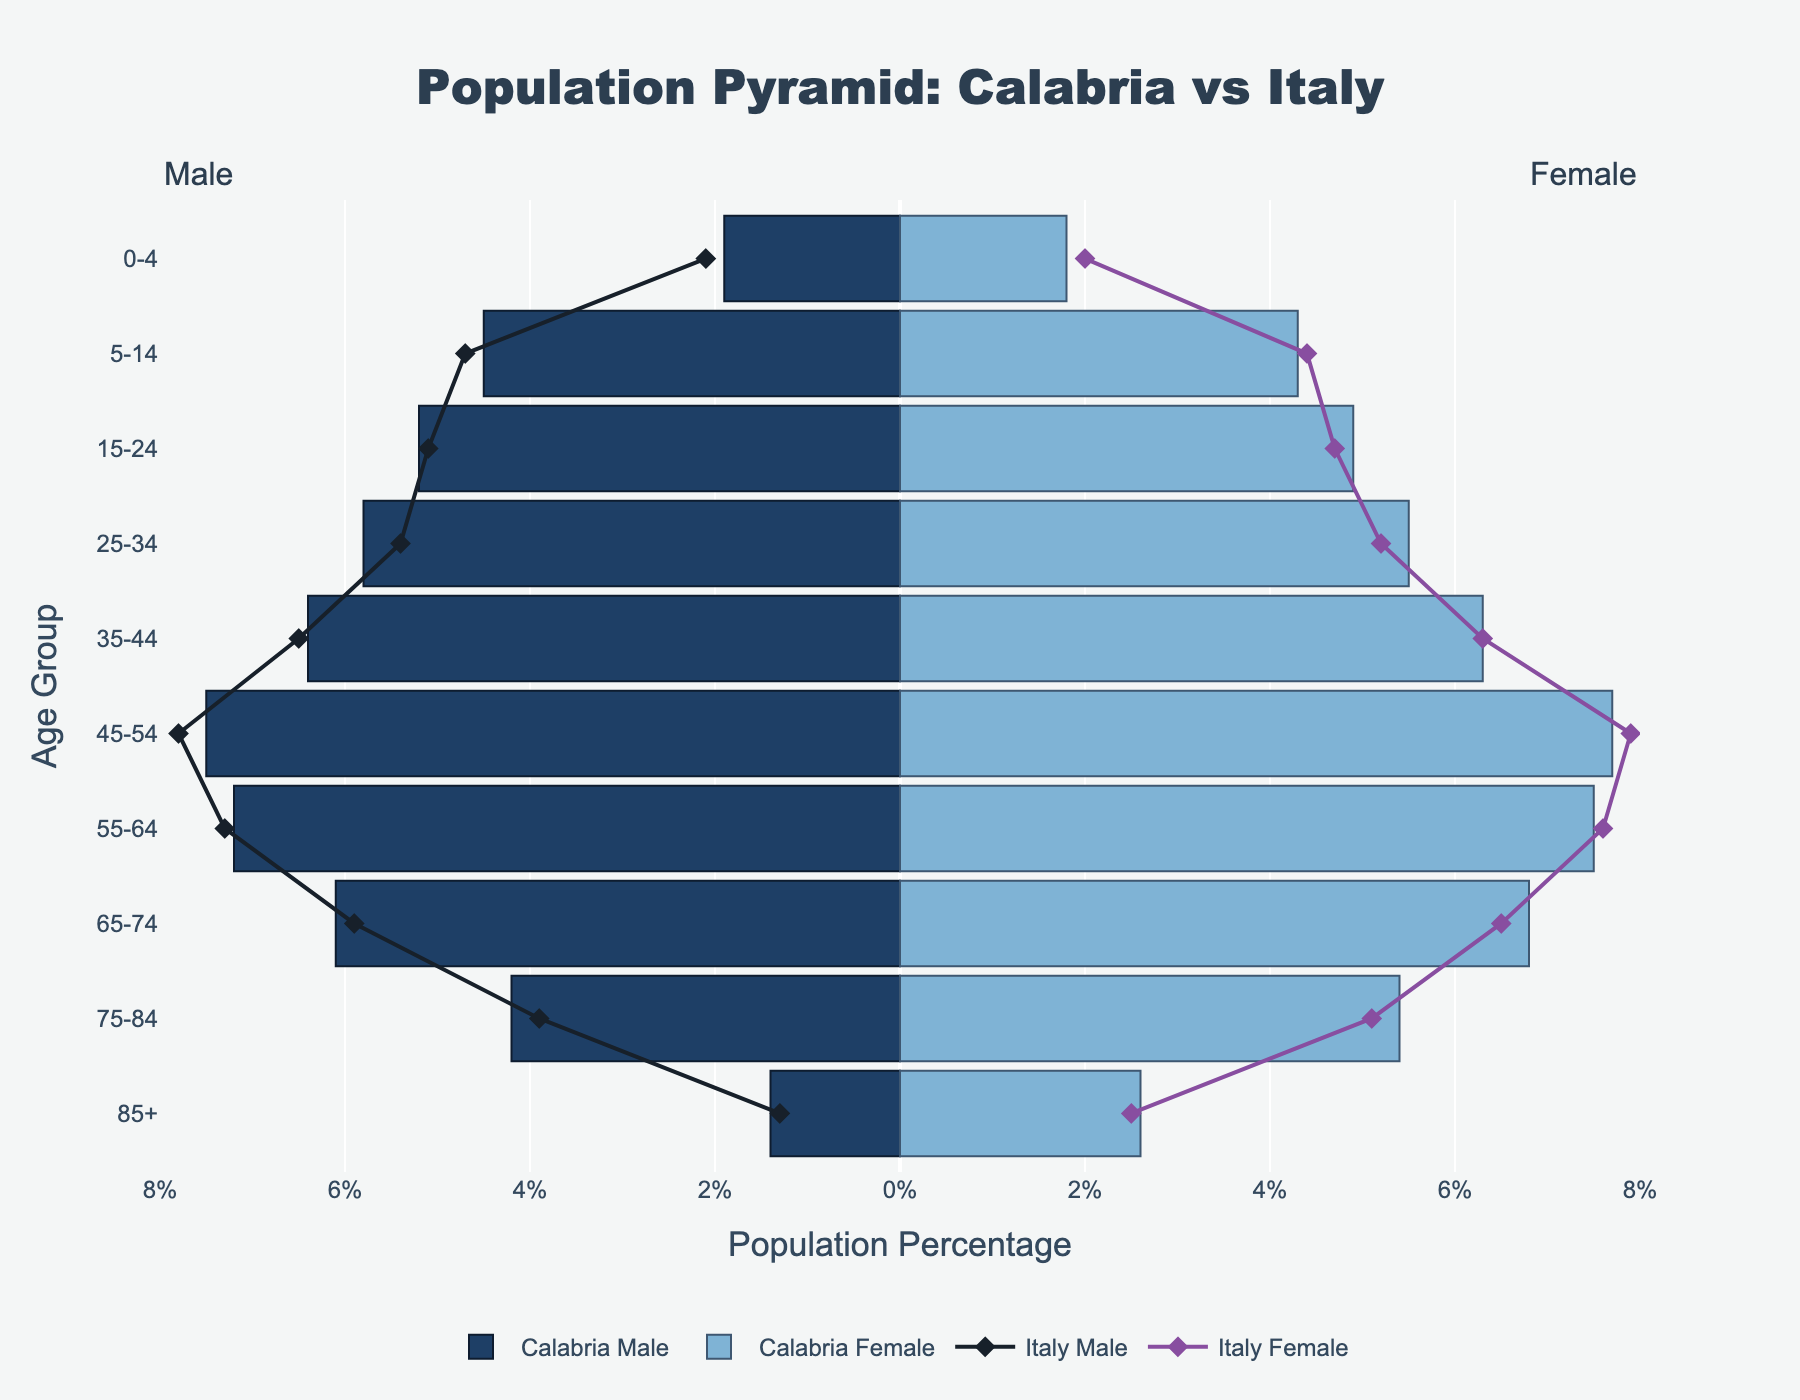What age group has the highest percentage of males in Calabria? The highest percentage of males in Calabria can be determined by looking at the bar lengths on the negative X-axis. The age group with the longest bar is the 45-54 group with 7.5%.
Answer: 45-54 What is the percentage difference between Calabria and Italy for males aged 0-4? The percentage for Calabria males aged 0-4 is 1.9%, and for Italy, it is 2.1%. The difference is calculated as 2.1% - 1.9% = 0.2%.
Answer: 0.2% How does the female population percentage in Calabria compare to Italy for the age group 85+? For the 85+ age group, Calabria has a female percentage of 2.6%, while Italy has a female percentage of 2.5%. Comparing these, Calabria is slightly higher.
Answer: Calabria is slightly higher Which age group has the largest difference between male and female percentages in Calabria? To find this, we compare the differences between male and female percentages for each age group. The age group 85+ shows the largest difference: 2.6% (female) - 1.4% (male) = 1.2%.
Answer: 85+ What age group shows a higher percentage for females compared to males in both Calabria and Italy? The age groups where both Calabria and Italy show females percentages higher than males percentages can be seen in the 45-54, 55-64, 65-74, 75-84, and 85+ age groups.
Answer: 45-54, 55-64, 65-74, 75-84, 85+ What is the total percentage of Calabria's population aged 25-44? Add the percentages of the age groups 25-34 (5.8% males + 5.5% females) and 35-44 (6.4% males + 6.3% females): 5.8 + 5.5 + 6.4 + 6.3 = 24%.
Answer: 24% Is the percentage of Calabria's female population aged 45-54 higher than Italy's? Compare the percentages: Calabria females aged 45-54 are 7.7%, and Italy females aged 45-54 are 7.9%. Therefore, Calabria is slightly lower.
Answer: No In which age group does Calabria have the largest male population percentage compared to Italy? Scanning the male bars, the largest difference where Calabria's percentage exceeds Italy's is the age group 25-34: Calabria 5.8% vs. Italy 5.4%.
Answer: 25-34 What is the percentage difference between males and females in Calabria for the age group 75-84? The percentage for Calabria males aged 75-84 is 4.2%, and for Calabria females, it is 5.4%. The difference is 5.4% - 4.2% = 1.2%.
Answer: 1.2% 